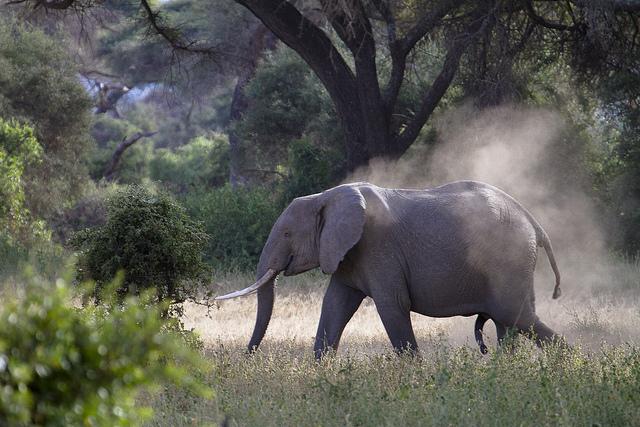Does this elephant have tusks?
Answer briefly. Yes. What is on the animals back?
Give a very brief answer. Dust. Is he in his natural setting?
Quick response, please. Yes. Is this tree in any danger?
Concise answer only. No. What sex is this elephant?
Be succinct. Male. Is that a coconut tree in the background?
Short answer required. No. How many tusks are visible?
Keep it brief. 1. Is the animal running?
Quick response, please. Yes. 